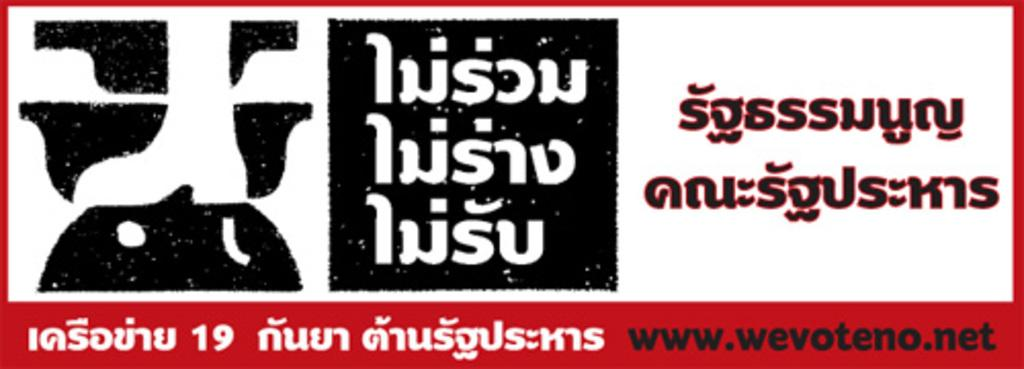What is present in the image that features an image and writing? There is a poster in the image that has an image and writing. What type of zinc is used to create the swing in the image? There is no swing present in the image, and therefore no zinc is used for it. 